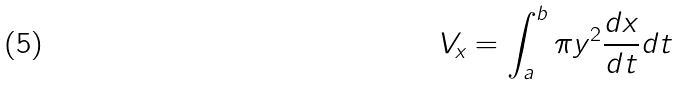<formula> <loc_0><loc_0><loc_500><loc_500>V _ { x } = \int _ { a } ^ { b } \pi y ^ { 2 } \frac { d x } { d t } d t</formula> 